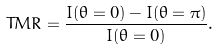<formula> <loc_0><loc_0><loc_500><loc_500>T M R = \frac { I ( \theta = 0 ) - I ( \theta = \pi ) } { I ( \theta = 0 ) } .</formula> 